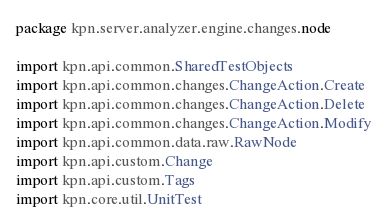<code> <loc_0><loc_0><loc_500><loc_500><_Scala_>package kpn.server.analyzer.engine.changes.node

import kpn.api.common.SharedTestObjects
import kpn.api.common.changes.ChangeAction.Create
import kpn.api.common.changes.ChangeAction.Delete
import kpn.api.common.changes.ChangeAction.Modify
import kpn.api.common.data.raw.RawNode
import kpn.api.custom.Change
import kpn.api.custom.Tags
import kpn.core.util.UnitTest</code> 